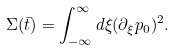<formula> <loc_0><loc_0><loc_500><loc_500>\Sigma ( \bar { t } ) = \int _ { - \infty } ^ { \infty } d \xi ( \partial _ { \xi } p _ { 0 } ) ^ { 2 } .</formula> 